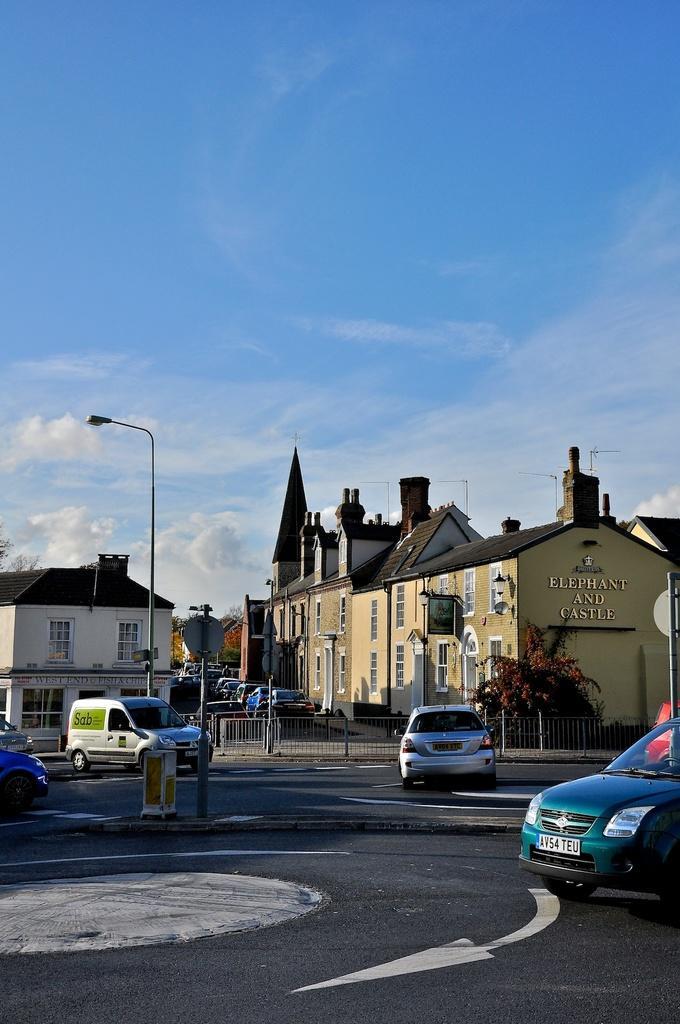In one or two sentences, can you explain what this image depicts? In this image, we can see buildings and barricades. There are vehicles on the road. There is a street pole in the middle of the image. In the background of the image, there is a sky. 